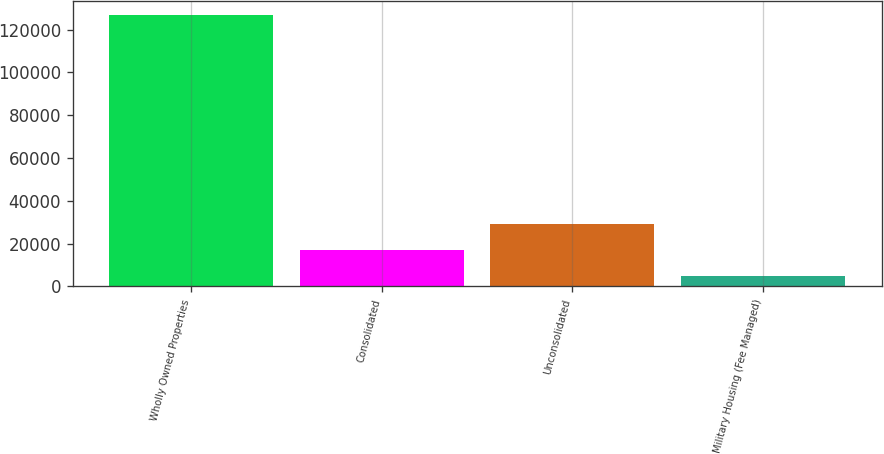Convert chart. <chart><loc_0><loc_0><loc_500><loc_500><bar_chart><fcel>Wholly Owned Properties<fcel>Consolidated<fcel>Unconsolidated<fcel>Military Housing (Fee Managed)<nl><fcel>127002<fcel>16938.3<fcel>29167.6<fcel>4709<nl></chart> 